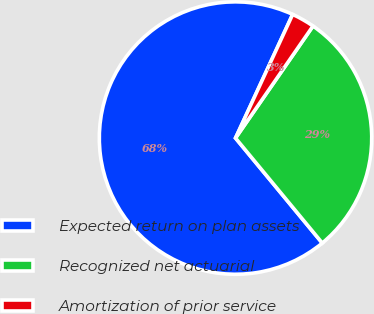Convert chart to OTSL. <chart><loc_0><loc_0><loc_500><loc_500><pie_chart><fcel>Expected return on plan assets<fcel>Recognized net actuarial<fcel>Amortization of prior service<nl><fcel>67.88%<fcel>29.38%<fcel>2.74%<nl></chart> 